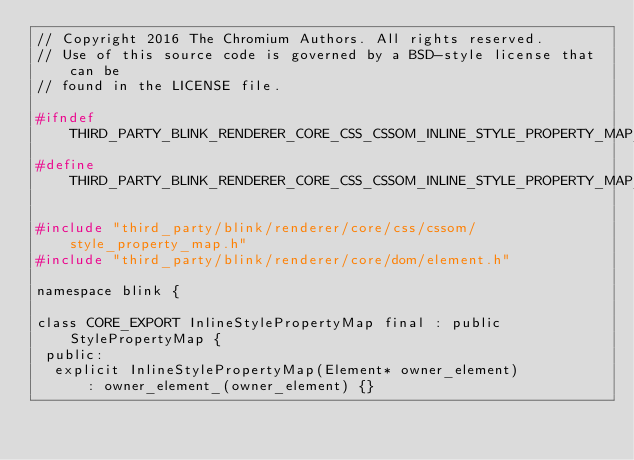Convert code to text. <code><loc_0><loc_0><loc_500><loc_500><_C_>// Copyright 2016 The Chromium Authors. All rights reserved.
// Use of this source code is governed by a BSD-style license that can be
// found in the LICENSE file.

#ifndef THIRD_PARTY_BLINK_RENDERER_CORE_CSS_CSSOM_INLINE_STYLE_PROPERTY_MAP_H_
#define THIRD_PARTY_BLINK_RENDERER_CORE_CSS_CSSOM_INLINE_STYLE_PROPERTY_MAP_H_

#include "third_party/blink/renderer/core/css/cssom/style_property_map.h"
#include "third_party/blink/renderer/core/dom/element.h"

namespace blink {

class CORE_EXPORT InlineStylePropertyMap final : public StylePropertyMap {
 public:
  explicit InlineStylePropertyMap(Element* owner_element)
      : owner_element_(owner_element) {}</code> 